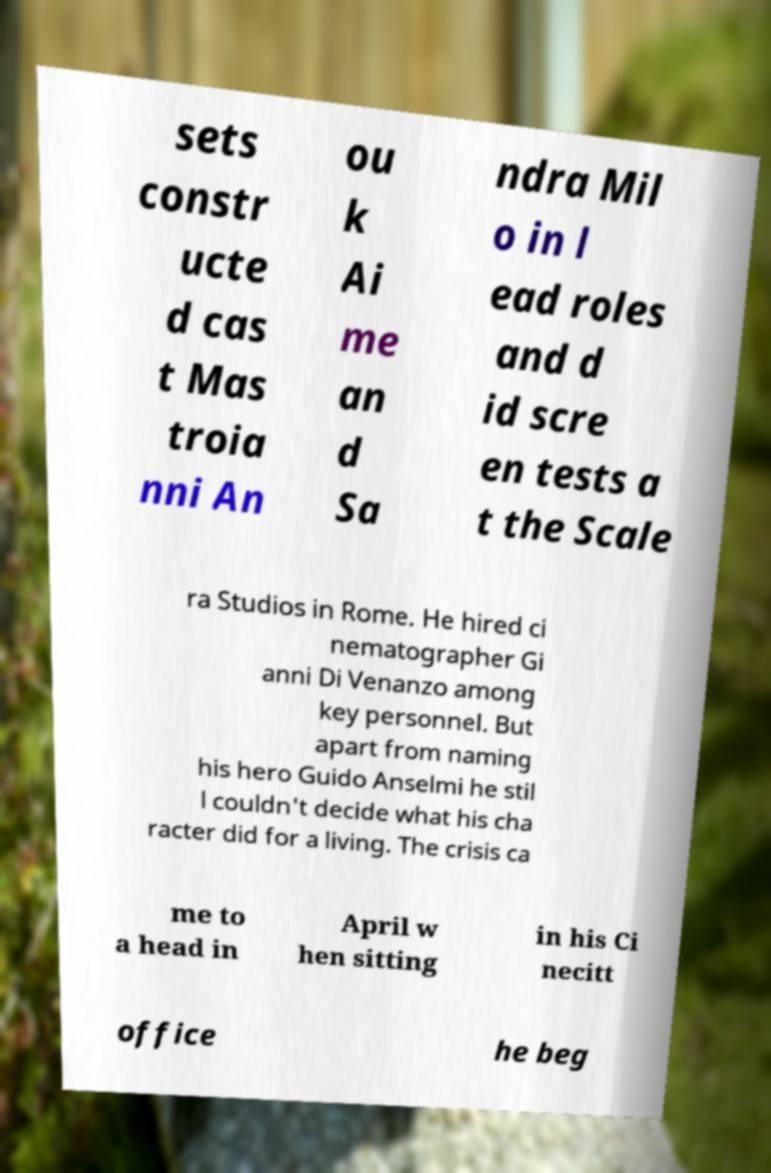Can you read and provide the text displayed in the image?This photo seems to have some interesting text. Can you extract and type it out for me? sets constr ucte d cas t Mas troia nni An ou k Ai me an d Sa ndra Mil o in l ead roles and d id scre en tests a t the Scale ra Studios in Rome. He hired ci nematographer Gi anni Di Venanzo among key personnel. But apart from naming his hero Guido Anselmi he stil l couldn't decide what his cha racter did for a living. The crisis ca me to a head in April w hen sitting in his Ci necitt office he beg 